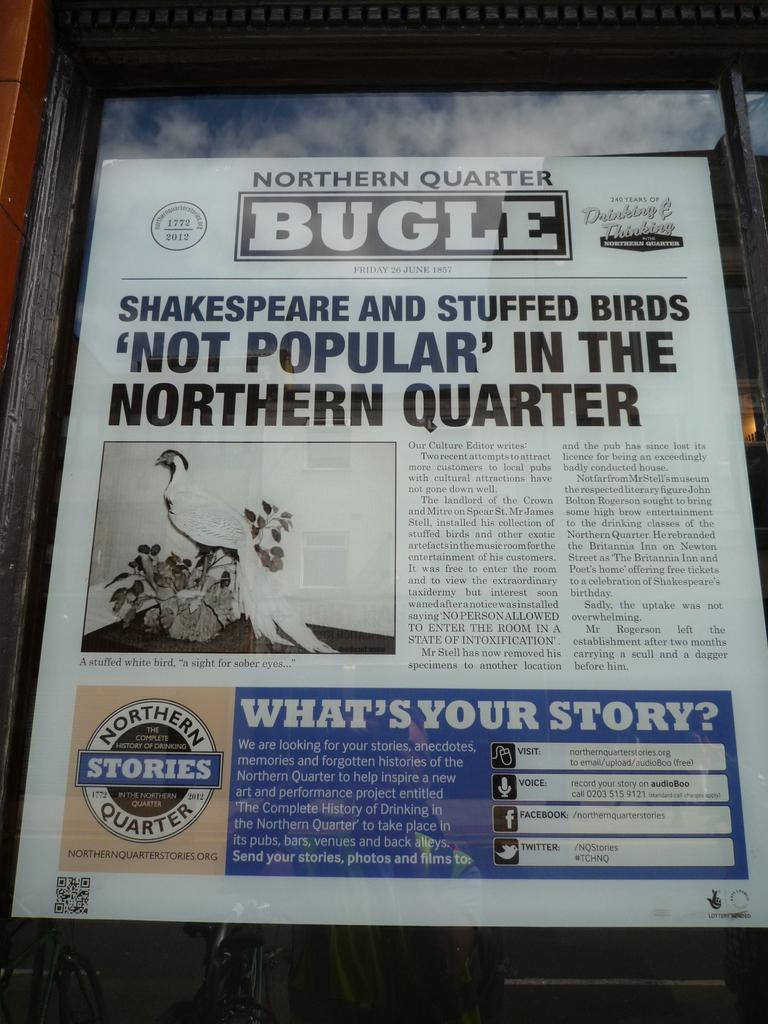<image>
Provide a brief description of the given image. A Northern Quarter Bugle with the years 1772 and 2012 in the left corner. 